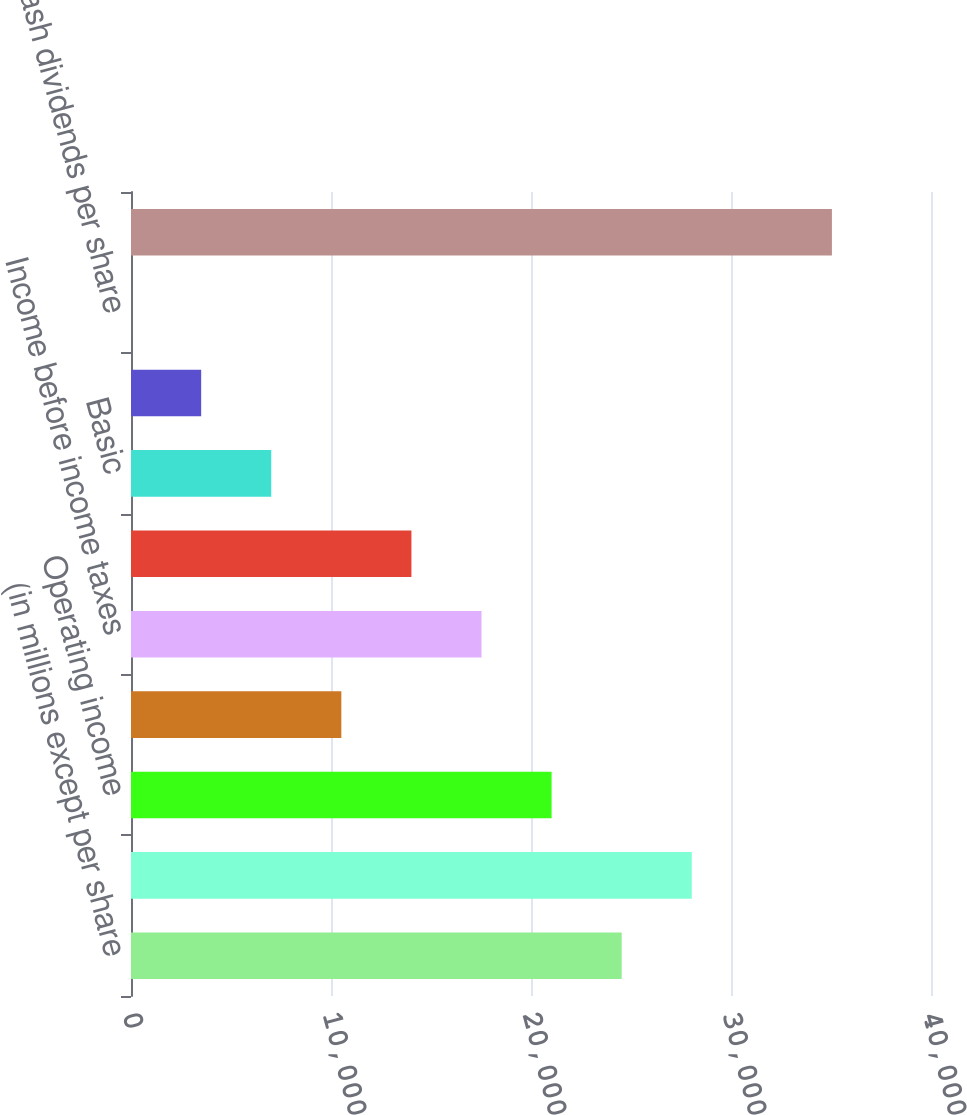Convert chart. <chart><loc_0><loc_0><loc_500><loc_500><bar_chart><fcel>(in millions except per share<fcel>Total revenues<fcel>Operating income<fcel>Non-operating income (expense)<fcel>Income before income taxes<fcel>Net income attributable to CME<fcel>Basic<fcel>Diluted<fcel>Cash dividends per share<fcel>Total assets<nl><fcel>24533.7<fcel>28037.8<fcel>21029.5<fcel>10517<fcel>17525.3<fcel>14021.2<fcel>7012.9<fcel>3508.75<fcel>4.6<fcel>35046.1<nl></chart> 